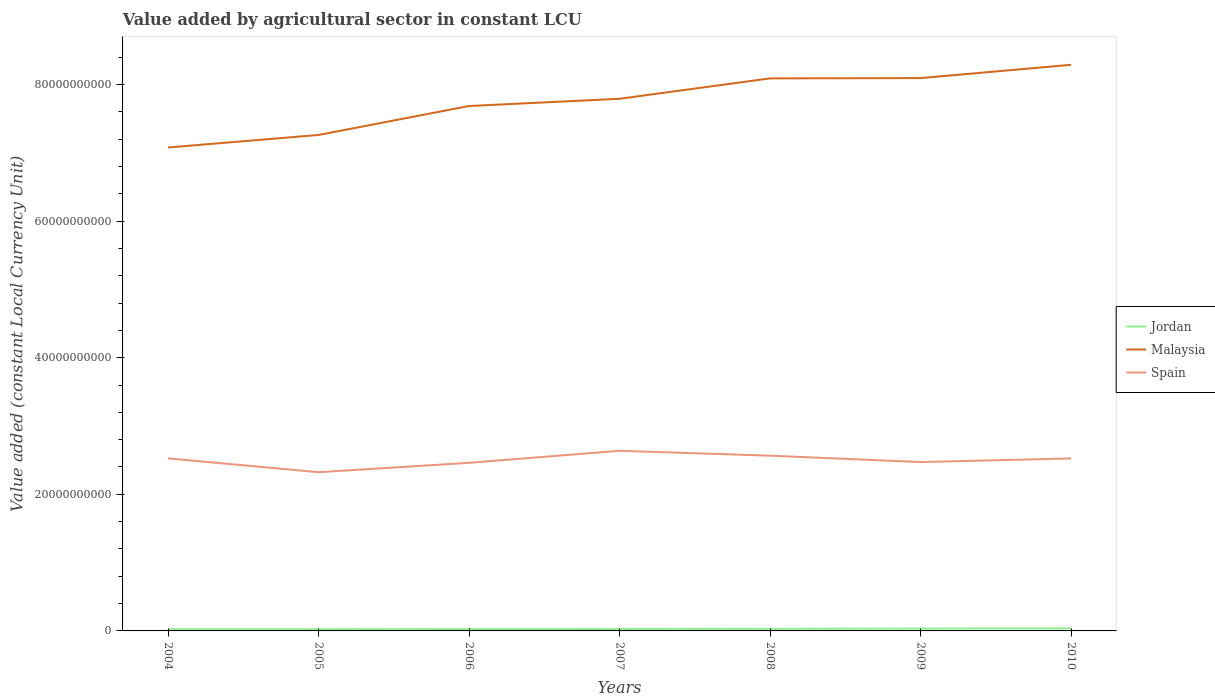Is the number of lines equal to the number of legend labels?
Offer a very short reply. Yes. Across all years, what is the maximum value added by agricultural sector in Malaysia?
Provide a short and direct response. 7.08e+1. In which year was the value added by agricultural sector in Spain maximum?
Your response must be concise. 2005. What is the total value added by agricultural sector in Spain in the graph?
Provide a succinct answer. 9.32e+08. What is the difference between the highest and the second highest value added by agricultural sector in Spain?
Offer a terse response. 3.14e+09. How many lines are there?
Your answer should be very brief. 3. Does the graph contain any zero values?
Give a very brief answer. No. How are the legend labels stacked?
Offer a very short reply. Vertical. What is the title of the graph?
Your answer should be compact. Value added by agricultural sector in constant LCU. What is the label or title of the X-axis?
Your answer should be compact. Years. What is the label or title of the Y-axis?
Ensure brevity in your answer.  Value added (constant Local Currency Unit). What is the Value added (constant Local Currency Unit) of Jordan in 2004?
Give a very brief answer. 2.47e+08. What is the Value added (constant Local Currency Unit) in Malaysia in 2004?
Your response must be concise. 7.08e+1. What is the Value added (constant Local Currency Unit) of Spain in 2004?
Ensure brevity in your answer.  2.53e+1. What is the Value added (constant Local Currency Unit) in Jordan in 2005?
Your answer should be compact. 2.48e+08. What is the Value added (constant Local Currency Unit) in Malaysia in 2005?
Offer a terse response. 7.26e+1. What is the Value added (constant Local Currency Unit) of Spain in 2005?
Offer a very short reply. 2.32e+1. What is the Value added (constant Local Currency Unit) of Jordan in 2006?
Give a very brief answer. 2.80e+08. What is the Value added (constant Local Currency Unit) in Malaysia in 2006?
Give a very brief answer. 7.68e+1. What is the Value added (constant Local Currency Unit) of Spain in 2006?
Give a very brief answer. 2.46e+1. What is the Value added (constant Local Currency Unit) of Jordan in 2007?
Make the answer very short. 2.83e+08. What is the Value added (constant Local Currency Unit) in Malaysia in 2007?
Your answer should be very brief. 7.79e+1. What is the Value added (constant Local Currency Unit) in Spain in 2007?
Provide a succinct answer. 2.64e+1. What is the Value added (constant Local Currency Unit) of Jordan in 2008?
Provide a succinct answer. 3.08e+08. What is the Value added (constant Local Currency Unit) of Malaysia in 2008?
Make the answer very short. 8.09e+1. What is the Value added (constant Local Currency Unit) in Spain in 2008?
Provide a succinct answer. 2.57e+1. What is the Value added (constant Local Currency Unit) of Jordan in 2009?
Provide a succinct answer. 3.47e+08. What is the Value added (constant Local Currency Unit) of Malaysia in 2009?
Keep it short and to the point. 8.09e+1. What is the Value added (constant Local Currency Unit) in Spain in 2009?
Keep it short and to the point. 2.47e+1. What is the Value added (constant Local Currency Unit) of Jordan in 2010?
Make the answer very short. 3.71e+08. What is the Value added (constant Local Currency Unit) of Malaysia in 2010?
Provide a succinct answer. 8.29e+1. What is the Value added (constant Local Currency Unit) in Spain in 2010?
Give a very brief answer. 2.53e+1. Across all years, what is the maximum Value added (constant Local Currency Unit) in Jordan?
Provide a succinct answer. 3.71e+08. Across all years, what is the maximum Value added (constant Local Currency Unit) in Malaysia?
Your response must be concise. 8.29e+1. Across all years, what is the maximum Value added (constant Local Currency Unit) of Spain?
Give a very brief answer. 2.64e+1. Across all years, what is the minimum Value added (constant Local Currency Unit) of Jordan?
Your answer should be very brief. 2.47e+08. Across all years, what is the minimum Value added (constant Local Currency Unit) of Malaysia?
Provide a short and direct response. 7.08e+1. Across all years, what is the minimum Value added (constant Local Currency Unit) of Spain?
Ensure brevity in your answer.  2.32e+1. What is the total Value added (constant Local Currency Unit) in Jordan in the graph?
Your answer should be very brief. 2.08e+09. What is the total Value added (constant Local Currency Unit) in Malaysia in the graph?
Offer a very short reply. 5.43e+11. What is the total Value added (constant Local Currency Unit) in Spain in the graph?
Your answer should be compact. 1.75e+11. What is the difference between the Value added (constant Local Currency Unit) in Jordan in 2004 and that in 2005?
Make the answer very short. -6.73e+05. What is the difference between the Value added (constant Local Currency Unit) in Malaysia in 2004 and that in 2005?
Ensure brevity in your answer.  -1.84e+09. What is the difference between the Value added (constant Local Currency Unit) in Spain in 2004 and that in 2005?
Keep it short and to the point. 2.03e+09. What is the difference between the Value added (constant Local Currency Unit) in Jordan in 2004 and that in 2006?
Give a very brief answer. -3.30e+07. What is the difference between the Value added (constant Local Currency Unit) in Malaysia in 2004 and that in 2006?
Offer a terse response. -6.07e+09. What is the difference between the Value added (constant Local Currency Unit) in Spain in 2004 and that in 2006?
Your answer should be very brief. 6.53e+08. What is the difference between the Value added (constant Local Currency Unit) in Jordan in 2004 and that in 2007?
Make the answer very short. -3.65e+07. What is the difference between the Value added (constant Local Currency Unit) of Malaysia in 2004 and that in 2007?
Offer a terse response. -7.13e+09. What is the difference between the Value added (constant Local Currency Unit) of Spain in 2004 and that in 2007?
Offer a very short reply. -1.11e+09. What is the difference between the Value added (constant Local Currency Unit) in Jordan in 2004 and that in 2008?
Provide a succinct answer. -6.09e+07. What is the difference between the Value added (constant Local Currency Unit) in Malaysia in 2004 and that in 2008?
Provide a succinct answer. -1.01e+1. What is the difference between the Value added (constant Local Currency Unit) of Spain in 2004 and that in 2008?
Keep it short and to the point. -3.93e+08. What is the difference between the Value added (constant Local Currency Unit) of Jordan in 2004 and that in 2009?
Ensure brevity in your answer.  -1.00e+08. What is the difference between the Value added (constant Local Currency Unit) in Malaysia in 2004 and that in 2009?
Offer a terse response. -1.02e+1. What is the difference between the Value added (constant Local Currency Unit) of Spain in 2004 and that in 2009?
Your answer should be very brief. 5.39e+08. What is the difference between the Value added (constant Local Currency Unit) of Jordan in 2004 and that in 2010?
Give a very brief answer. -1.24e+08. What is the difference between the Value added (constant Local Currency Unit) in Malaysia in 2004 and that in 2010?
Make the answer very short. -1.21e+1. What is the difference between the Value added (constant Local Currency Unit) in Spain in 2004 and that in 2010?
Offer a very short reply. 1.00e+07. What is the difference between the Value added (constant Local Currency Unit) in Jordan in 2005 and that in 2006?
Give a very brief answer. -3.24e+07. What is the difference between the Value added (constant Local Currency Unit) in Malaysia in 2005 and that in 2006?
Your answer should be very brief. -4.24e+09. What is the difference between the Value added (constant Local Currency Unit) in Spain in 2005 and that in 2006?
Offer a terse response. -1.38e+09. What is the difference between the Value added (constant Local Currency Unit) of Jordan in 2005 and that in 2007?
Your answer should be compact. -3.58e+07. What is the difference between the Value added (constant Local Currency Unit) of Malaysia in 2005 and that in 2007?
Keep it short and to the point. -5.30e+09. What is the difference between the Value added (constant Local Currency Unit) in Spain in 2005 and that in 2007?
Offer a terse response. -3.14e+09. What is the difference between the Value added (constant Local Currency Unit) in Jordan in 2005 and that in 2008?
Your response must be concise. -6.02e+07. What is the difference between the Value added (constant Local Currency Unit) in Malaysia in 2005 and that in 2008?
Give a very brief answer. -8.28e+09. What is the difference between the Value added (constant Local Currency Unit) of Spain in 2005 and that in 2008?
Ensure brevity in your answer.  -2.42e+09. What is the difference between the Value added (constant Local Currency Unit) in Jordan in 2005 and that in 2009?
Give a very brief answer. -9.97e+07. What is the difference between the Value added (constant Local Currency Unit) in Malaysia in 2005 and that in 2009?
Make the answer very short. -8.33e+09. What is the difference between the Value added (constant Local Currency Unit) of Spain in 2005 and that in 2009?
Your answer should be very brief. -1.49e+09. What is the difference between the Value added (constant Local Currency Unit) in Jordan in 2005 and that in 2010?
Provide a succinct answer. -1.24e+08. What is the difference between the Value added (constant Local Currency Unit) in Malaysia in 2005 and that in 2010?
Your answer should be very brief. -1.03e+1. What is the difference between the Value added (constant Local Currency Unit) in Spain in 2005 and that in 2010?
Offer a very short reply. -2.02e+09. What is the difference between the Value added (constant Local Currency Unit) of Jordan in 2006 and that in 2007?
Your response must be concise. -3.44e+06. What is the difference between the Value added (constant Local Currency Unit) of Malaysia in 2006 and that in 2007?
Ensure brevity in your answer.  -1.06e+09. What is the difference between the Value added (constant Local Currency Unit) of Spain in 2006 and that in 2007?
Your answer should be very brief. -1.76e+09. What is the difference between the Value added (constant Local Currency Unit) of Jordan in 2006 and that in 2008?
Keep it short and to the point. -2.79e+07. What is the difference between the Value added (constant Local Currency Unit) of Malaysia in 2006 and that in 2008?
Keep it short and to the point. -4.05e+09. What is the difference between the Value added (constant Local Currency Unit) of Spain in 2006 and that in 2008?
Make the answer very short. -1.05e+09. What is the difference between the Value added (constant Local Currency Unit) of Jordan in 2006 and that in 2009?
Offer a very short reply. -6.74e+07. What is the difference between the Value added (constant Local Currency Unit) in Malaysia in 2006 and that in 2009?
Your response must be concise. -4.09e+09. What is the difference between the Value added (constant Local Currency Unit) in Spain in 2006 and that in 2009?
Offer a very short reply. -1.14e+08. What is the difference between the Value added (constant Local Currency Unit) of Jordan in 2006 and that in 2010?
Ensure brevity in your answer.  -9.14e+07. What is the difference between the Value added (constant Local Currency Unit) of Malaysia in 2006 and that in 2010?
Provide a short and direct response. -6.04e+09. What is the difference between the Value added (constant Local Currency Unit) of Spain in 2006 and that in 2010?
Provide a short and direct response. -6.43e+08. What is the difference between the Value added (constant Local Currency Unit) of Jordan in 2007 and that in 2008?
Your answer should be compact. -2.44e+07. What is the difference between the Value added (constant Local Currency Unit) of Malaysia in 2007 and that in 2008?
Ensure brevity in your answer.  -2.99e+09. What is the difference between the Value added (constant Local Currency Unit) in Spain in 2007 and that in 2008?
Provide a short and direct response. 7.15e+08. What is the difference between the Value added (constant Local Currency Unit) in Jordan in 2007 and that in 2009?
Keep it short and to the point. -6.39e+07. What is the difference between the Value added (constant Local Currency Unit) in Malaysia in 2007 and that in 2009?
Your answer should be very brief. -3.03e+09. What is the difference between the Value added (constant Local Currency Unit) of Spain in 2007 and that in 2009?
Make the answer very short. 1.65e+09. What is the difference between the Value added (constant Local Currency Unit) in Jordan in 2007 and that in 2010?
Provide a short and direct response. -8.79e+07. What is the difference between the Value added (constant Local Currency Unit) of Malaysia in 2007 and that in 2010?
Give a very brief answer. -4.98e+09. What is the difference between the Value added (constant Local Currency Unit) in Spain in 2007 and that in 2010?
Give a very brief answer. 1.12e+09. What is the difference between the Value added (constant Local Currency Unit) of Jordan in 2008 and that in 2009?
Your answer should be very brief. -3.95e+07. What is the difference between the Value added (constant Local Currency Unit) in Malaysia in 2008 and that in 2009?
Your answer should be very brief. -4.20e+07. What is the difference between the Value added (constant Local Currency Unit) in Spain in 2008 and that in 2009?
Provide a succinct answer. 9.32e+08. What is the difference between the Value added (constant Local Currency Unit) in Jordan in 2008 and that in 2010?
Your answer should be very brief. -6.35e+07. What is the difference between the Value added (constant Local Currency Unit) of Malaysia in 2008 and that in 2010?
Provide a succinct answer. -1.99e+09. What is the difference between the Value added (constant Local Currency Unit) of Spain in 2008 and that in 2010?
Offer a very short reply. 4.03e+08. What is the difference between the Value added (constant Local Currency Unit) in Jordan in 2009 and that in 2010?
Your answer should be very brief. -2.40e+07. What is the difference between the Value added (constant Local Currency Unit) of Malaysia in 2009 and that in 2010?
Your answer should be very brief. -1.95e+09. What is the difference between the Value added (constant Local Currency Unit) of Spain in 2009 and that in 2010?
Give a very brief answer. -5.29e+08. What is the difference between the Value added (constant Local Currency Unit) of Jordan in 2004 and the Value added (constant Local Currency Unit) of Malaysia in 2005?
Provide a succinct answer. -7.24e+1. What is the difference between the Value added (constant Local Currency Unit) of Jordan in 2004 and the Value added (constant Local Currency Unit) of Spain in 2005?
Your response must be concise. -2.30e+1. What is the difference between the Value added (constant Local Currency Unit) in Malaysia in 2004 and the Value added (constant Local Currency Unit) in Spain in 2005?
Provide a succinct answer. 4.75e+1. What is the difference between the Value added (constant Local Currency Unit) of Jordan in 2004 and the Value added (constant Local Currency Unit) of Malaysia in 2006?
Provide a short and direct response. -7.66e+1. What is the difference between the Value added (constant Local Currency Unit) of Jordan in 2004 and the Value added (constant Local Currency Unit) of Spain in 2006?
Offer a very short reply. -2.44e+1. What is the difference between the Value added (constant Local Currency Unit) of Malaysia in 2004 and the Value added (constant Local Currency Unit) of Spain in 2006?
Give a very brief answer. 4.62e+1. What is the difference between the Value added (constant Local Currency Unit) of Jordan in 2004 and the Value added (constant Local Currency Unit) of Malaysia in 2007?
Ensure brevity in your answer.  -7.77e+1. What is the difference between the Value added (constant Local Currency Unit) in Jordan in 2004 and the Value added (constant Local Currency Unit) in Spain in 2007?
Offer a terse response. -2.61e+1. What is the difference between the Value added (constant Local Currency Unit) of Malaysia in 2004 and the Value added (constant Local Currency Unit) of Spain in 2007?
Make the answer very short. 4.44e+1. What is the difference between the Value added (constant Local Currency Unit) of Jordan in 2004 and the Value added (constant Local Currency Unit) of Malaysia in 2008?
Your response must be concise. -8.06e+1. What is the difference between the Value added (constant Local Currency Unit) of Jordan in 2004 and the Value added (constant Local Currency Unit) of Spain in 2008?
Your answer should be compact. -2.54e+1. What is the difference between the Value added (constant Local Currency Unit) in Malaysia in 2004 and the Value added (constant Local Currency Unit) in Spain in 2008?
Provide a succinct answer. 4.51e+1. What is the difference between the Value added (constant Local Currency Unit) in Jordan in 2004 and the Value added (constant Local Currency Unit) in Malaysia in 2009?
Ensure brevity in your answer.  -8.07e+1. What is the difference between the Value added (constant Local Currency Unit) in Jordan in 2004 and the Value added (constant Local Currency Unit) in Spain in 2009?
Your response must be concise. -2.45e+1. What is the difference between the Value added (constant Local Currency Unit) in Malaysia in 2004 and the Value added (constant Local Currency Unit) in Spain in 2009?
Provide a short and direct response. 4.60e+1. What is the difference between the Value added (constant Local Currency Unit) of Jordan in 2004 and the Value added (constant Local Currency Unit) of Malaysia in 2010?
Keep it short and to the point. -8.26e+1. What is the difference between the Value added (constant Local Currency Unit) of Jordan in 2004 and the Value added (constant Local Currency Unit) of Spain in 2010?
Your answer should be compact. -2.50e+1. What is the difference between the Value added (constant Local Currency Unit) in Malaysia in 2004 and the Value added (constant Local Currency Unit) in Spain in 2010?
Make the answer very short. 4.55e+1. What is the difference between the Value added (constant Local Currency Unit) in Jordan in 2005 and the Value added (constant Local Currency Unit) in Malaysia in 2006?
Make the answer very short. -7.66e+1. What is the difference between the Value added (constant Local Currency Unit) of Jordan in 2005 and the Value added (constant Local Currency Unit) of Spain in 2006?
Offer a terse response. -2.44e+1. What is the difference between the Value added (constant Local Currency Unit) of Malaysia in 2005 and the Value added (constant Local Currency Unit) of Spain in 2006?
Offer a terse response. 4.80e+1. What is the difference between the Value added (constant Local Currency Unit) of Jordan in 2005 and the Value added (constant Local Currency Unit) of Malaysia in 2007?
Give a very brief answer. -7.77e+1. What is the difference between the Value added (constant Local Currency Unit) in Jordan in 2005 and the Value added (constant Local Currency Unit) in Spain in 2007?
Offer a very short reply. -2.61e+1. What is the difference between the Value added (constant Local Currency Unit) of Malaysia in 2005 and the Value added (constant Local Currency Unit) of Spain in 2007?
Your answer should be very brief. 4.62e+1. What is the difference between the Value added (constant Local Currency Unit) of Jordan in 2005 and the Value added (constant Local Currency Unit) of Malaysia in 2008?
Your answer should be very brief. -8.06e+1. What is the difference between the Value added (constant Local Currency Unit) of Jordan in 2005 and the Value added (constant Local Currency Unit) of Spain in 2008?
Your response must be concise. -2.54e+1. What is the difference between the Value added (constant Local Currency Unit) in Malaysia in 2005 and the Value added (constant Local Currency Unit) in Spain in 2008?
Make the answer very short. 4.70e+1. What is the difference between the Value added (constant Local Currency Unit) of Jordan in 2005 and the Value added (constant Local Currency Unit) of Malaysia in 2009?
Your response must be concise. -8.07e+1. What is the difference between the Value added (constant Local Currency Unit) in Jordan in 2005 and the Value added (constant Local Currency Unit) in Spain in 2009?
Your response must be concise. -2.45e+1. What is the difference between the Value added (constant Local Currency Unit) in Malaysia in 2005 and the Value added (constant Local Currency Unit) in Spain in 2009?
Your answer should be very brief. 4.79e+1. What is the difference between the Value added (constant Local Currency Unit) in Jordan in 2005 and the Value added (constant Local Currency Unit) in Malaysia in 2010?
Your answer should be very brief. -8.26e+1. What is the difference between the Value added (constant Local Currency Unit) in Jordan in 2005 and the Value added (constant Local Currency Unit) in Spain in 2010?
Give a very brief answer. -2.50e+1. What is the difference between the Value added (constant Local Currency Unit) in Malaysia in 2005 and the Value added (constant Local Currency Unit) in Spain in 2010?
Provide a succinct answer. 4.74e+1. What is the difference between the Value added (constant Local Currency Unit) in Jordan in 2006 and the Value added (constant Local Currency Unit) in Malaysia in 2007?
Provide a short and direct response. -7.76e+1. What is the difference between the Value added (constant Local Currency Unit) of Jordan in 2006 and the Value added (constant Local Currency Unit) of Spain in 2007?
Ensure brevity in your answer.  -2.61e+1. What is the difference between the Value added (constant Local Currency Unit) in Malaysia in 2006 and the Value added (constant Local Currency Unit) in Spain in 2007?
Provide a short and direct response. 5.05e+1. What is the difference between the Value added (constant Local Currency Unit) in Jordan in 2006 and the Value added (constant Local Currency Unit) in Malaysia in 2008?
Your answer should be compact. -8.06e+1. What is the difference between the Value added (constant Local Currency Unit) of Jordan in 2006 and the Value added (constant Local Currency Unit) of Spain in 2008?
Provide a succinct answer. -2.54e+1. What is the difference between the Value added (constant Local Currency Unit) of Malaysia in 2006 and the Value added (constant Local Currency Unit) of Spain in 2008?
Ensure brevity in your answer.  5.12e+1. What is the difference between the Value added (constant Local Currency Unit) of Jordan in 2006 and the Value added (constant Local Currency Unit) of Malaysia in 2009?
Keep it short and to the point. -8.07e+1. What is the difference between the Value added (constant Local Currency Unit) in Jordan in 2006 and the Value added (constant Local Currency Unit) in Spain in 2009?
Provide a short and direct response. -2.44e+1. What is the difference between the Value added (constant Local Currency Unit) of Malaysia in 2006 and the Value added (constant Local Currency Unit) of Spain in 2009?
Keep it short and to the point. 5.21e+1. What is the difference between the Value added (constant Local Currency Unit) of Jordan in 2006 and the Value added (constant Local Currency Unit) of Malaysia in 2010?
Make the answer very short. -8.26e+1. What is the difference between the Value added (constant Local Currency Unit) of Jordan in 2006 and the Value added (constant Local Currency Unit) of Spain in 2010?
Give a very brief answer. -2.50e+1. What is the difference between the Value added (constant Local Currency Unit) of Malaysia in 2006 and the Value added (constant Local Currency Unit) of Spain in 2010?
Provide a succinct answer. 5.16e+1. What is the difference between the Value added (constant Local Currency Unit) in Jordan in 2007 and the Value added (constant Local Currency Unit) in Malaysia in 2008?
Give a very brief answer. -8.06e+1. What is the difference between the Value added (constant Local Currency Unit) in Jordan in 2007 and the Value added (constant Local Currency Unit) in Spain in 2008?
Offer a very short reply. -2.54e+1. What is the difference between the Value added (constant Local Currency Unit) in Malaysia in 2007 and the Value added (constant Local Currency Unit) in Spain in 2008?
Your answer should be compact. 5.22e+1. What is the difference between the Value added (constant Local Currency Unit) of Jordan in 2007 and the Value added (constant Local Currency Unit) of Malaysia in 2009?
Your answer should be very brief. -8.07e+1. What is the difference between the Value added (constant Local Currency Unit) in Jordan in 2007 and the Value added (constant Local Currency Unit) in Spain in 2009?
Your response must be concise. -2.44e+1. What is the difference between the Value added (constant Local Currency Unit) of Malaysia in 2007 and the Value added (constant Local Currency Unit) of Spain in 2009?
Provide a short and direct response. 5.32e+1. What is the difference between the Value added (constant Local Currency Unit) of Jordan in 2007 and the Value added (constant Local Currency Unit) of Malaysia in 2010?
Your answer should be compact. -8.26e+1. What is the difference between the Value added (constant Local Currency Unit) of Jordan in 2007 and the Value added (constant Local Currency Unit) of Spain in 2010?
Offer a terse response. -2.50e+1. What is the difference between the Value added (constant Local Currency Unit) in Malaysia in 2007 and the Value added (constant Local Currency Unit) in Spain in 2010?
Ensure brevity in your answer.  5.27e+1. What is the difference between the Value added (constant Local Currency Unit) in Jordan in 2008 and the Value added (constant Local Currency Unit) in Malaysia in 2009?
Give a very brief answer. -8.06e+1. What is the difference between the Value added (constant Local Currency Unit) in Jordan in 2008 and the Value added (constant Local Currency Unit) in Spain in 2009?
Provide a succinct answer. -2.44e+1. What is the difference between the Value added (constant Local Currency Unit) of Malaysia in 2008 and the Value added (constant Local Currency Unit) of Spain in 2009?
Give a very brief answer. 5.62e+1. What is the difference between the Value added (constant Local Currency Unit) in Jordan in 2008 and the Value added (constant Local Currency Unit) in Malaysia in 2010?
Offer a terse response. -8.26e+1. What is the difference between the Value added (constant Local Currency Unit) in Jordan in 2008 and the Value added (constant Local Currency Unit) in Spain in 2010?
Your answer should be very brief. -2.49e+1. What is the difference between the Value added (constant Local Currency Unit) of Malaysia in 2008 and the Value added (constant Local Currency Unit) of Spain in 2010?
Offer a terse response. 5.56e+1. What is the difference between the Value added (constant Local Currency Unit) in Jordan in 2009 and the Value added (constant Local Currency Unit) in Malaysia in 2010?
Give a very brief answer. -8.25e+1. What is the difference between the Value added (constant Local Currency Unit) in Jordan in 2009 and the Value added (constant Local Currency Unit) in Spain in 2010?
Ensure brevity in your answer.  -2.49e+1. What is the difference between the Value added (constant Local Currency Unit) in Malaysia in 2009 and the Value added (constant Local Currency Unit) in Spain in 2010?
Provide a succinct answer. 5.57e+1. What is the average Value added (constant Local Currency Unit) in Jordan per year?
Offer a very short reply. 2.98e+08. What is the average Value added (constant Local Currency Unit) of Malaysia per year?
Provide a succinct answer. 7.75e+1. What is the average Value added (constant Local Currency Unit) of Spain per year?
Provide a short and direct response. 2.50e+1. In the year 2004, what is the difference between the Value added (constant Local Currency Unit) in Jordan and Value added (constant Local Currency Unit) in Malaysia?
Offer a very short reply. -7.05e+1. In the year 2004, what is the difference between the Value added (constant Local Currency Unit) in Jordan and Value added (constant Local Currency Unit) in Spain?
Offer a terse response. -2.50e+1. In the year 2004, what is the difference between the Value added (constant Local Currency Unit) in Malaysia and Value added (constant Local Currency Unit) in Spain?
Keep it short and to the point. 4.55e+1. In the year 2005, what is the difference between the Value added (constant Local Currency Unit) in Jordan and Value added (constant Local Currency Unit) in Malaysia?
Offer a very short reply. -7.24e+1. In the year 2005, what is the difference between the Value added (constant Local Currency Unit) of Jordan and Value added (constant Local Currency Unit) of Spain?
Provide a short and direct response. -2.30e+1. In the year 2005, what is the difference between the Value added (constant Local Currency Unit) in Malaysia and Value added (constant Local Currency Unit) in Spain?
Provide a succinct answer. 4.94e+1. In the year 2006, what is the difference between the Value added (constant Local Currency Unit) in Jordan and Value added (constant Local Currency Unit) in Malaysia?
Offer a terse response. -7.66e+1. In the year 2006, what is the difference between the Value added (constant Local Currency Unit) of Jordan and Value added (constant Local Currency Unit) of Spain?
Your answer should be very brief. -2.43e+1. In the year 2006, what is the difference between the Value added (constant Local Currency Unit) in Malaysia and Value added (constant Local Currency Unit) in Spain?
Offer a terse response. 5.22e+1. In the year 2007, what is the difference between the Value added (constant Local Currency Unit) of Jordan and Value added (constant Local Currency Unit) of Malaysia?
Your response must be concise. -7.76e+1. In the year 2007, what is the difference between the Value added (constant Local Currency Unit) of Jordan and Value added (constant Local Currency Unit) of Spain?
Keep it short and to the point. -2.61e+1. In the year 2007, what is the difference between the Value added (constant Local Currency Unit) in Malaysia and Value added (constant Local Currency Unit) in Spain?
Provide a short and direct response. 5.15e+1. In the year 2008, what is the difference between the Value added (constant Local Currency Unit) in Jordan and Value added (constant Local Currency Unit) in Malaysia?
Your answer should be compact. -8.06e+1. In the year 2008, what is the difference between the Value added (constant Local Currency Unit) of Jordan and Value added (constant Local Currency Unit) of Spain?
Ensure brevity in your answer.  -2.53e+1. In the year 2008, what is the difference between the Value added (constant Local Currency Unit) of Malaysia and Value added (constant Local Currency Unit) of Spain?
Keep it short and to the point. 5.52e+1. In the year 2009, what is the difference between the Value added (constant Local Currency Unit) in Jordan and Value added (constant Local Currency Unit) in Malaysia?
Your response must be concise. -8.06e+1. In the year 2009, what is the difference between the Value added (constant Local Currency Unit) of Jordan and Value added (constant Local Currency Unit) of Spain?
Provide a succinct answer. -2.44e+1. In the year 2009, what is the difference between the Value added (constant Local Currency Unit) of Malaysia and Value added (constant Local Currency Unit) of Spain?
Your answer should be very brief. 5.62e+1. In the year 2010, what is the difference between the Value added (constant Local Currency Unit) in Jordan and Value added (constant Local Currency Unit) in Malaysia?
Keep it short and to the point. -8.25e+1. In the year 2010, what is the difference between the Value added (constant Local Currency Unit) of Jordan and Value added (constant Local Currency Unit) of Spain?
Give a very brief answer. -2.49e+1. In the year 2010, what is the difference between the Value added (constant Local Currency Unit) of Malaysia and Value added (constant Local Currency Unit) of Spain?
Your response must be concise. 5.76e+1. What is the ratio of the Value added (constant Local Currency Unit) in Jordan in 2004 to that in 2005?
Provide a succinct answer. 1. What is the ratio of the Value added (constant Local Currency Unit) in Malaysia in 2004 to that in 2005?
Provide a short and direct response. 0.97. What is the ratio of the Value added (constant Local Currency Unit) of Spain in 2004 to that in 2005?
Keep it short and to the point. 1.09. What is the ratio of the Value added (constant Local Currency Unit) of Jordan in 2004 to that in 2006?
Your response must be concise. 0.88. What is the ratio of the Value added (constant Local Currency Unit) in Malaysia in 2004 to that in 2006?
Provide a succinct answer. 0.92. What is the ratio of the Value added (constant Local Currency Unit) in Spain in 2004 to that in 2006?
Keep it short and to the point. 1.03. What is the ratio of the Value added (constant Local Currency Unit) in Jordan in 2004 to that in 2007?
Provide a short and direct response. 0.87. What is the ratio of the Value added (constant Local Currency Unit) of Malaysia in 2004 to that in 2007?
Your response must be concise. 0.91. What is the ratio of the Value added (constant Local Currency Unit) in Spain in 2004 to that in 2007?
Your answer should be compact. 0.96. What is the ratio of the Value added (constant Local Currency Unit) in Jordan in 2004 to that in 2008?
Your response must be concise. 0.8. What is the ratio of the Value added (constant Local Currency Unit) in Malaysia in 2004 to that in 2008?
Offer a very short reply. 0.87. What is the ratio of the Value added (constant Local Currency Unit) in Spain in 2004 to that in 2008?
Provide a succinct answer. 0.98. What is the ratio of the Value added (constant Local Currency Unit) in Jordan in 2004 to that in 2009?
Your answer should be compact. 0.71. What is the ratio of the Value added (constant Local Currency Unit) in Malaysia in 2004 to that in 2009?
Offer a terse response. 0.87. What is the ratio of the Value added (constant Local Currency Unit) of Spain in 2004 to that in 2009?
Give a very brief answer. 1.02. What is the ratio of the Value added (constant Local Currency Unit) of Jordan in 2004 to that in 2010?
Give a very brief answer. 0.66. What is the ratio of the Value added (constant Local Currency Unit) of Malaysia in 2004 to that in 2010?
Offer a terse response. 0.85. What is the ratio of the Value added (constant Local Currency Unit) of Spain in 2004 to that in 2010?
Keep it short and to the point. 1. What is the ratio of the Value added (constant Local Currency Unit) of Jordan in 2005 to that in 2006?
Ensure brevity in your answer.  0.88. What is the ratio of the Value added (constant Local Currency Unit) in Malaysia in 2005 to that in 2006?
Provide a succinct answer. 0.94. What is the ratio of the Value added (constant Local Currency Unit) in Spain in 2005 to that in 2006?
Provide a succinct answer. 0.94. What is the ratio of the Value added (constant Local Currency Unit) in Jordan in 2005 to that in 2007?
Your answer should be compact. 0.87. What is the ratio of the Value added (constant Local Currency Unit) in Malaysia in 2005 to that in 2007?
Make the answer very short. 0.93. What is the ratio of the Value added (constant Local Currency Unit) of Spain in 2005 to that in 2007?
Offer a very short reply. 0.88. What is the ratio of the Value added (constant Local Currency Unit) in Jordan in 2005 to that in 2008?
Give a very brief answer. 0.8. What is the ratio of the Value added (constant Local Currency Unit) in Malaysia in 2005 to that in 2008?
Give a very brief answer. 0.9. What is the ratio of the Value added (constant Local Currency Unit) of Spain in 2005 to that in 2008?
Offer a very short reply. 0.91. What is the ratio of the Value added (constant Local Currency Unit) in Jordan in 2005 to that in 2009?
Ensure brevity in your answer.  0.71. What is the ratio of the Value added (constant Local Currency Unit) in Malaysia in 2005 to that in 2009?
Your response must be concise. 0.9. What is the ratio of the Value added (constant Local Currency Unit) in Spain in 2005 to that in 2009?
Keep it short and to the point. 0.94. What is the ratio of the Value added (constant Local Currency Unit) in Jordan in 2005 to that in 2010?
Ensure brevity in your answer.  0.67. What is the ratio of the Value added (constant Local Currency Unit) of Malaysia in 2005 to that in 2010?
Give a very brief answer. 0.88. What is the ratio of the Value added (constant Local Currency Unit) of Spain in 2005 to that in 2010?
Provide a short and direct response. 0.92. What is the ratio of the Value added (constant Local Currency Unit) of Malaysia in 2006 to that in 2007?
Provide a succinct answer. 0.99. What is the ratio of the Value added (constant Local Currency Unit) of Spain in 2006 to that in 2007?
Keep it short and to the point. 0.93. What is the ratio of the Value added (constant Local Currency Unit) in Jordan in 2006 to that in 2008?
Provide a succinct answer. 0.91. What is the ratio of the Value added (constant Local Currency Unit) in Malaysia in 2006 to that in 2008?
Keep it short and to the point. 0.95. What is the ratio of the Value added (constant Local Currency Unit) in Spain in 2006 to that in 2008?
Give a very brief answer. 0.96. What is the ratio of the Value added (constant Local Currency Unit) in Jordan in 2006 to that in 2009?
Ensure brevity in your answer.  0.81. What is the ratio of the Value added (constant Local Currency Unit) of Malaysia in 2006 to that in 2009?
Ensure brevity in your answer.  0.95. What is the ratio of the Value added (constant Local Currency Unit) in Jordan in 2006 to that in 2010?
Ensure brevity in your answer.  0.75. What is the ratio of the Value added (constant Local Currency Unit) of Malaysia in 2006 to that in 2010?
Offer a very short reply. 0.93. What is the ratio of the Value added (constant Local Currency Unit) in Spain in 2006 to that in 2010?
Keep it short and to the point. 0.97. What is the ratio of the Value added (constant Local Currency Unit) in Jordan in 2007 to that in 2008?
Your response must be concise. 0.92. What is the ratio of the Value added (constant Local Currency Unit) of Malaysia in 2007 to that in 2008?
Make the answer very short. 0.96. What is the ratio of the Value added (constant Local Currency Unit) of Spain in 2007 to that in 2008?
Your answer should be compact. 1.03. What is the ratio of the Value added (constant Local Currency Unit) of Jordan in 2007 to that in 2009?
Offer a terse response. 0.82. What is the ratio of the Value added (constant Local Currency Unit) in Malaysia in 2007 to that in 2009?
Give a very brief answer. 0.96. What is the ratio of the Value added (constant Local Currency Unit) in Spain in 2007 to that in 2009?
Your answer should be very brief. 1.07. What is the ratio of the Value added (constant Local Currency Unit) of Jordan in 2007 to that in 2010?
Keep it short and to the point. 0.76. What is the ratio of the Value added (constant Local Currency Unit) in Malaysia in 2007 to that in 2010?
Your response must be concise. 0.94. What is the ratio of the Value added (constant Local Currency Unit) in Spain in 2007 to that in 2010?
Your response must be concise. 1.04. What is the ratio of the Value added (constant Local Currency Unit) of Jordan in 2008 to that in 2009?
Your answer should be very brief. 0.89. What is the ratio of the Value added (constant Local Currency Unit) of Malaysia in 2008 to that in 2009?
Provide a short and direct response. 1. What is the ratio of the Value added (constant Local Currency Unit) in Spain in 2008 to that in 2009?
Offer a terse response. 1.04. What is the ratio of the Value added (constant Local Currency Unit) of Jordan in 2008 to that in 2010?
Offer a terse response. 0.83. What is the ratio of the Value added (constant Local Currency Unit) of Malaysia in 2008 to that in 2010?
Keep it short and to the point. 0.98. What is the ratio of the Value added (constant Local Currency Unit) of Jordan in 2009 to that in 2010?
Your answer should be compact. 0.94. What is the ratio of the Value added (constant Local Currency Unit) of Malaysia in 2009 to that in 2010?
Keep it short and to the point. 0.98. What is the ratio of the Value added (constant Local Currency Unit) in Spain in 2009 to that in 2010?
Make the answer very short. 0.98. What is the difference between the highest and the second highest Value added (constant Local Currency Unit) in Jordan?
Provide a succinct answer. 2.40e+07. What is the difference between the highest and the second highest Value added (constant Local Currency Unit) in Malaysia?
Your answer should be very brief. 1.95e+09. What is the difference between the highest and the second highest Value added (constant Local Currency Unit) in Spain?
Give a very brief answer. 7.15e+08. What is the difference between the highest and the lowest Value added (constant Local Currency Unit) in Jordan?
Give a very brief answer. 1.24e+08. What is the difference between the highest and the lowest Value added (constant Local Currency Unit) of Malaysia?
Provide a short and direct response. 1.21e+1. What is the difference between the highest and the lowest Value added (constant Local Currency Unit) in Spain?
Offer a terse response. 3.14e+09. 